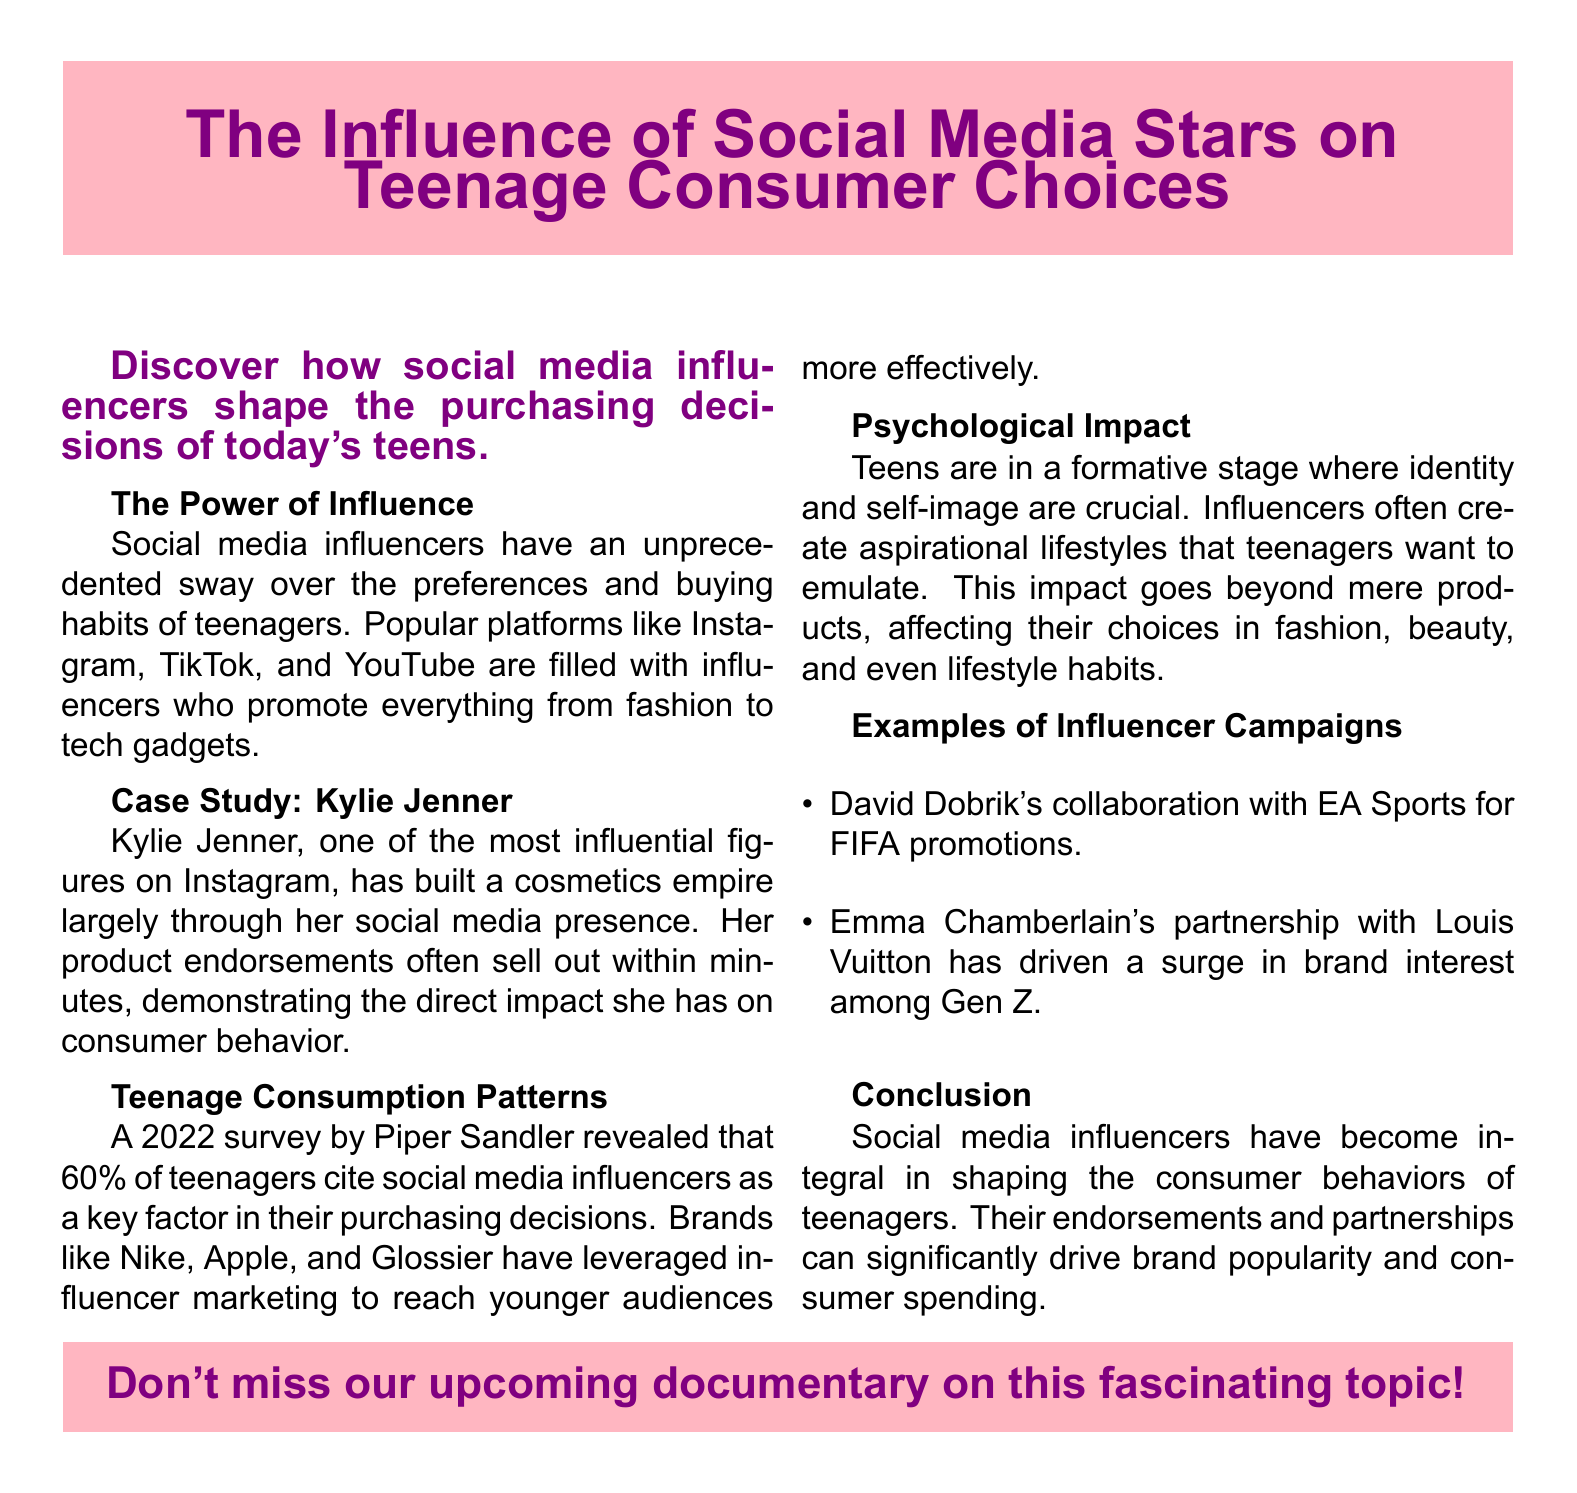What percentage of teenagers cite social media influencers as a key factor in their purchasing decisions? The document states that 60% of teenagers consider influencers a significant factor in their purchases.
Answer: 60% Who is mentioned as a prominent social media influencer with a cosmetics empire? Kylie Jenner is highlighted as a key figure affecting consumer behavior in the beauty industry.
Answer: Kylie Jenner Which brands have leveraged influencer marketing to reach younger audiences? The document lists Nike, Apple, and Glossier as brands using influencer marketing effectively.
Answer: Nike, Apple, Glossier What kind of lifestyles do influencers create that affect teenage consumers? Influencers create aspirational lifestyles that teenagers want to emulate, impacting their choices significantly.
Answer: Aspirational lifestyles What is the title of the upcoming documentary mentioned in the advertisement? The document encourages viewers not to miss the upcoming documentary but does not specify its title, focusing instead on social media influences.
Answer: Upcoming documentary 